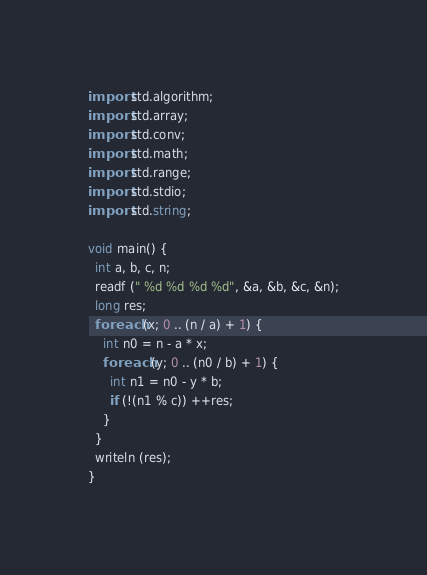<code> <loc_0><loc_0><loc_500><loc_500><_D_>import std.algorithm;
import std.array;
import std.conv;
import std.math;
import std.range;
import std.stdio;
import std.string;

void main() {
  int a, b, c, n;
  readf (" %d %d %d %d", &a, &b, &c, &n);
  long res;
  foreach (x; 0 .. (n / a) + 1) {
    int n0 = n - a * x;
    foreach (y; 0 .. (n0 / b) + 1) {
      int n1 = n0 - y * b;
      if (!(n1 % c)) ++res;
    }
  }
  writeln (res);
}
</code> 